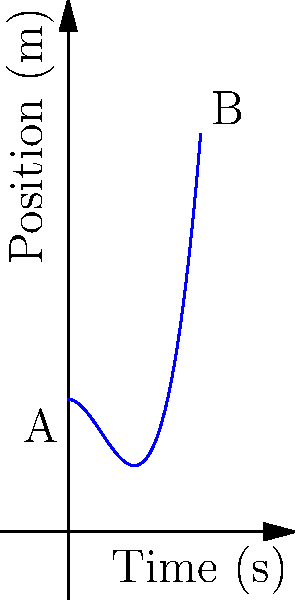In this PowerPoint slide, we have a graph representing the position of an object over time. The curve is described by the function $f(t) = 2t^3 - 3t^2 + 2$, where $t$ is time in seconds and $f(t)$ is position in meters. What is the instantaneous velocity of the object at $t = 1$ second? To find the instantaneous velocity at $t = 1$, we need to calculate the derivative of the position function at that point. Here's how we do it:

1) The position function is $f(t) = 2t^3 - 3t^2 + 2$

2) The velocity function is the derivative of the position function:
   $$v(t) = f'(t) = 6t^2 - 6t$$

3) To find the instantaneous velocity at $t = 1$, we substitute $t = 1$ into the velocity function:
   $$v(1) = 6(1)^2 - 6(1) = 6 - 6 = 0$$

Therefore, the instantaneous velocity at $t = 1$ second is 0 m/s.

This result indicates that at exactly 1 second, the object momentarily comes to rest, which corresponds to the turning point of the curve in the graph.
Answer: 0 m/s 